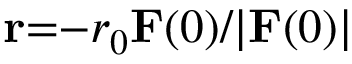<formula> <loc_0><loc_0><loc_500><loc_500>r { = } { - } r _ { 0 } F ( 0 ) / | F ( 0 ) |</formula> 